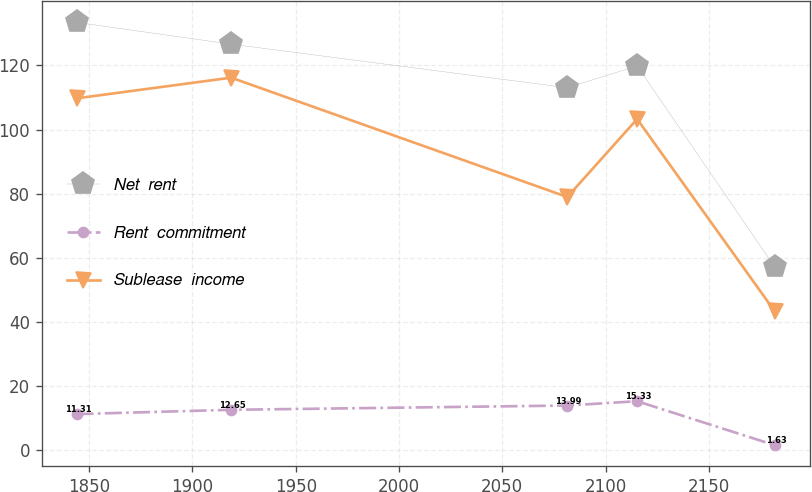Convert chart. <chart><loc_0><loc_0><loc_500><loc_500><line_chart><ecel><fcel>Net  rent<fcel>Rent  commitment<fcel>Sublease  income<nl><fcel>1843.85<fcel>133.4<fcel>11.31<fcel>109.72<nl><fcel>1918.74<fcel>126.61<fcel>12.65<fcel>116.17<nl><fcel>2081.49<fcel>113.03<fcel>13.99<fcel>78.97<nl><fcel>2115.3<fcel>119.82<fcel>15.33<fcel>103.27<nl><fcel>2181.91<fcel>57.2<fcel>1.63<fcel>43.37<nl></chart> 